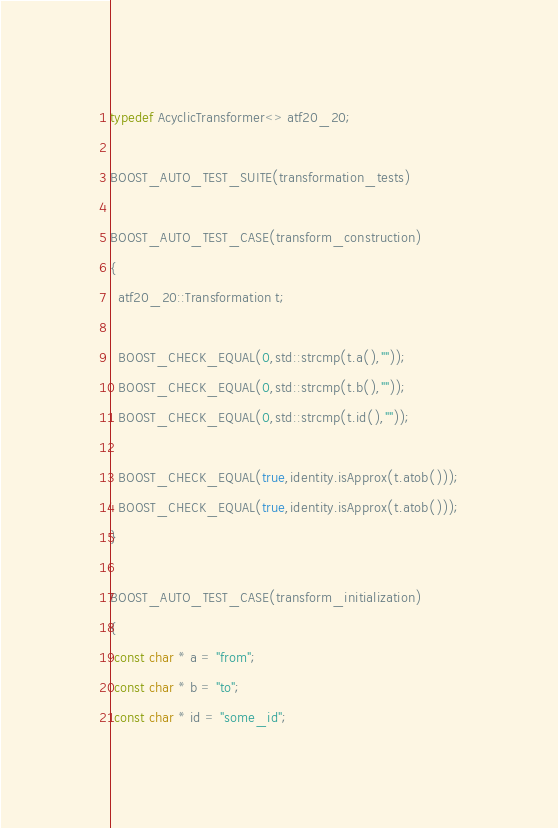<code> <loc_0><loc_0><loc_500><loc_500><_C++_>
typedef AcyclicTransformer<> atf20_20;

BOOST_AUTO_TEST_SUITE(transformation_tests)

BOOST_AUTO_TEST_CASE(transform_construction)
{
  atf20_20::Transformation t;

  BOOST_CHECK_EQUAL(0,std::strcmp(t.a(),""));
  BOOST_CHECK_EQUAL(0,std::strcmp(t.b(),""));
  BOOST_CHECK_EQUAL(0,std::strcmp(t.id(),""));

  BOOST_CHECK_EQUAL(true,identity.isApprox(t.atob()));
  BOOST_CHECK_EQUAL(true,identity.isApprox(t.atob()));
}

BOOST_AUTO_TEST_CASE(transform_initialization)
{
 const char * a = "from";
 const char * b = "to";
 const char * id = "some_id";
</code> 